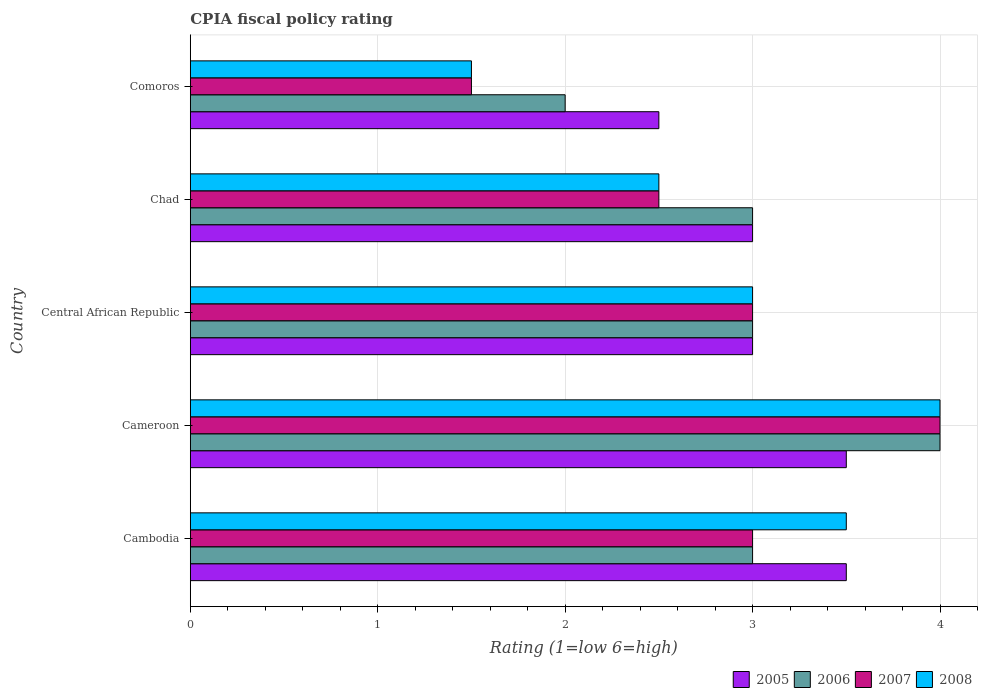How many different coloured bars are there?
Provide a short and direct response. 4. How many groups of bars are there?
Provide a short and direct response. 5. How many bars are there on the 3rd tick from the bottom?
Your answer should be very brief. 4. What is the label of the 4th group of bars from the top?
Give a very brief answer. Cameroon. Across all countries, what is the minimum CPIA rating in 2007?
Keep it short and to the point. 1.5. In which country was the CPIA rating in 2007 maximum?
Your answer should be very brief. Cameroon. In which country was the CPIA rating in 2006 minimum?
Make the answer very short. Comoros. What is the difference between the CPIA rating in 2008 in Cambodia and that in Comoros?
Provide a short and direct response. 2. What is the average CPIA rating in 2008 per country?
Offer a very short reply. 2.9. In how many countries, is the CPIA rating in 2006 greater than 0.2 ?
Your response must be concise. 5. What is the ratio of the CPIA rating in 2008 in Cameroon to that in Central African Republic?
Offer a very short reply. 1.33. Is the CPIA rating in 2005 in Cameroon less than that in Chad?
Your response must be concise. No. What is the difference between the highest and the lowest CPIA rating in 2005?
Your answer should be compact. 1. In how many countries, is the CPIA rating in 2006 greater than the average CPIA rating in 2006 taken over all countries?
Your response must be concise. 1. Is the sum of the CPIA rating in 2007 in Chad and Comoros greater than the maximum CPIA rating in 2006 across all countries?
Your response must be concise. No. Is it the case that in every country, the sum of the CPIA rating in 2008 and CPIA rating in 2005 is greater than the sum of CPIA rating in 2006 and CPIA rating in 2007?
Provide a short and direct response. No. Is it the case that in every country, the sum of the CPIA rating in 2008 and CPIA rating in 2007 is greater than the CPIA rating in 2006?
Ensure brevity in your answer.  Yes. Are all the bars in the graph horizontal?
Make the answer very short. Yes. How many countries are there in the graph?
Offer a terse response. 5. Does the graph contain grids?
Provide a succinct answer. Yes. How many legend labels are there?
Offer a very short reply. 4. What is the title of the graph?
Your answer should be compact. CPIA fiscal policy rating. Does "1984" appear as one of the legend labels in the graph?
Offer a terse response. No. What is the label or title of the X-axis?
Give a very brief answer. Rating (1=low 6=high). What is the Rating (1=low 6=high) in 2006 in Cambodia?
Offer a terse response. 3. What is the Rating (1=low 6=high) in 2007 in Cambodia?
Keep it short and to the point. 3. What is the Rating (1=low 6=high) in 2008 in Cambodia?
Give a very brief answer. 3.5. What is the Rating (1=low 6=high) of 2007 in Cameroon?
Offer a terse response. 4. What is the Rating (1=low 6=high) in 2005 in Central African Republic?
Your response must be concise. 3. What is the Rating (1=low 6=high) in 2006 in Central African Republic?
Offer a terse response. 3. What is the Rating (1=low 6=high) of 2007 in Central African Republic?
Your answer should be very brief. 3. What is the Rating (1=low 6=high) of 2005 in Chad?
Offer a terse response. 3. What is the Rating (1=low 6=high) in 2007 in Chad?
Provide a short and direct response. 2.5. What is the Rating (1=low 6=high) in 2006 in Comoros?
Provide a short and direct response. 2. What is the Rating (1=low 6=high) in 2007 in Comoros?
Give a very brief answer. 1.5. What is the Rating (1=low 6=high) of 2008 in Comoros?
Your response must be concise. 1.5. Across all countries, what is the maximum Rating (1=low 6=high) of 2007?
Offer a very short reply. 4. Across all countries, what is the maximum Rating (1=low 6=high) of 2008?
Offer a terse response. 4. What is the total Rating (1=low 6=high) of 2006 in the graph?
Offer a terse response. 15. What is the total Rating (1=low 6=high) of 2007 in the graph?
Provide a short and direct response. 14. What is the difference between the Rating (1=low 6=high) in 2005 in Cambodia and that in Cameroon?
Your response must be concise. 0. What is the difference between the Rating (1=low 6=high) of 2007 in Cambodia and that in Cameroon?
Keep it short and to the point. -1. What is the difference between the Rating (1=low 6=high) in 2005 in Cambodia and that in Central African Republic?
Give a very brief answer. 0.5. What is the difference between the Rating (1=low 6=high) of 2006 in Cambodia and that in Central African Republic?
Provide a short and direct response. 0. What is the difference between the Rating (1=low 6=high) in 2007 in Cambodia and that in Central African Republic?
Your response must be concise. 0. What is the difference between the Rating (1=low 6=high) of 2006 in Cambodia and that in Chad?
Provide a short and direct response. 0. What is the difference between the Rating (1=low 6=high) in 2007 in Cambodia and that in Chad?
Keep it short and to the point. 0.5. What is the difference between the Rating (1=low 6=high) of 2008 in Cambodia and that in Chad?
Give a very brief answer. 1. What is the difference between the Rating (1=low 6=high) of 2005 in Cambodia and that in Comoros?
Your response must be concise. 1. What is the difference between the Rating (1=low 6=high) in 2006 in Cambodia and that in Comoros?
Offer a terse response. 1. What is the difference between the Rating (1=low 6=high) of 2007 in Cambodia and that in Comoros?
Ensure brevity in your answer.  1.5. What is the difference between the Rating (1=low 6=high) of 2007 in Cameroon and that in Central African Republic?
Provide a succinct answer. 1. What is the difference between the Rating (1=low 6=high) in 2006 in Cameroon and that in Chad?
Your response must be concise. 1. What is the difference between the Rating (1=low 6=high) in 2008 in Cameroon and that in Chad?
Your answer should be very brief. 1.5. What is the difference between the Rating (1=low 6=high) of 2005 in Cameroon and that in Comoros?
Make the answer very short. 1. What is the difference between the Rating (1=low 6=high) in 2008 in Cameroon and that in Comoros?
Your response must be concise. 2.5. What is the difference between the Rating (1=low 6=high) in 2005 in Central African Republic and that in Comoros?
Offer a very short reply. 0.5. What is the difference between the Rating (1=low 6=high) in 2006 in Central African Republic and that in Comoros?
Your answer should be compact. 1. What is the difference between the Rating (1=low 6=high) in 2007 in Central African Republic and that in Comoros?
Offer a terse response. 1.5. What is the difference between the Rating (1=low 6=high) of 2005 in Chad and that in Comoros?
Your answer should be compact. 0.5. What is the difference between the Rating (1=low 6=high) in 2006 in Chad and that in Comoros?
Your response must be concise. 1. What is the difference between the Rating (1=low 6=high) in 2007 in Chad and that in Comoros?
Ensure brevity in your answer.  1. What is the difference between the Rating (1=low 6=high) of 2008 in Chad and that in Comoros?
Your response must be concise. 1. What is the difference between the Rating (1=low 6=high) of 2005 in Cambodia and the Rating (1=low 6=high) of 2006 in Cameroon?
Provide a short and direct response. -0.5. What is the difference between the Rating (1=low 6=high) of 2005 in Cambodia and the Rating (1=low 6=high) of 2007 in Cameroon?
Make the answer very short. -0.5. What is the difference between the Rating (1=low 6=high) in 2005 in Cambodia and the Rating (1=low 6=high) in 2008 in Cameroon?
Give a very brief answer. -0.5. What is the difference between the Rating (1=low 6=high) in 2006 in Cambodia and the Rating (1=low 6=high) in 2008 in Cameroon?
Your answer should be compact. -1. What is the difference between the Rating (1=low 6=high) of 2007 in Cambodia and the Rating (1=low 6=high) of 2008 in Cameroon?
Keep it short and to the point. -1. What is the difference between the Rating (1=low 6=high) in 2005 in Cambodia and the Rating (1=low 6=high) in 2007 in Central African Republic?
Give a very brief answer. 0.5. What is the difference between the Rating (1=low 6=high) of 2006 in Cambodia and the Rating (1=low 6=high) of 2007 in Central African Republic?
Offer a terse response. 0. What is the difference between the Rating (1=low 6=high) of 2007 in Cambodia and the Rating (1=low 6=high) of 2008 in Central African Republic?
Give a very brief answer. 0. What is the difference between the Rating (1=low 6=high) in 2006 in Cambodia and the Rating (1=low 6=high) in 2007 in Chad?
Ensure brevity in your answer.  0.5. What is the difference between the Rating (1=low 6=high) of 2005 in Cambodia and the Rating (1=low 6=high) of 2008 in Comoros?
Your answer should be compact. 2. What is the difference between the Rating (1=low 6=high) in 2006 in Cameroon and the Rating (1=low 6=high) in 2008 in Central African Republic?
Your answer should be compact. 1. What is the difference between the Rating (1=low 6=high) of 2007 in Cameroon and the Rating (1=low 6=high) of 2008 in Central African Republic?
Make the answer very short. 1. What is the difference between the Rating (1=low 6=high) of 2006 in Cameroon and the Rating (1=low 6=high) of 2008 in Chad?
Provide a short and direct response. 1.5. What is the difference between the Rating (1=low 6=high) in 2005 in Cameroon and the Rating (1=low 6=high) in 2008 in Comoros?
Your answer should be compact. 2. What is the difference between the Rating (1=low 6=high) of 2006 in Cameroon and the Rating (1=low 6=high) of 2008 in Comoros?
Offer a terse response. 2.5. What is the difference between the Rating (1=low 6=high) of 2006 in Central African Republic and the Rating (1=low 6=high) of 2007 in Chad?
Keep it short and to the point. 0.5. What is the difference between the Rating (1=low 6=high) of 2005 in Central African Republic and the Rating (1=low 6=high) of 2007 in Comoros?
Provide a short and direct response. 1.5. What is the difference between the Rating (1=low 6=high) in 2005 in Central African Republic and the Rating (1=low 6=high) in 2008 in Comoros?
Ensure brevity in your answer.  1.5. What is the difference between the Rating (1=low 6=high) of 2006 in Central African Republic and the Rating (1=low 6=high) of 2007 in Comoros?
Provide a short and direct response. 1.5. What is the difference between the Rating (1=low 6=high) in 2006 in Central African Republic and the Rating (1=low 6=high) in 2008 in Comoros?
Provide a succinct answer. 1.5. What is the difference between the Rating (1=low 6=high) of 2007 in Central African Republic and the Rating (1=low 6=high) of 2008 in Comoros?
Make the answer very short. 1.5. What is the difference between the Rating (1=low 6=high) of 2005 in Chad and the Rating (1=low 6=high) of 2006 in Comoros?
Offer a terse response. 1. What is the difference between the Rating (1=low 6=high) of 2005 in Chad and the Rating (1=low 6=high) of 2007 in Comoros?
Provide a short and direct response. 1.5. What is the difference between the Rating (1=low 6=high) of 2006 in Chad and the Rating (1=low 6=high) of 2008 in Comoros?
Your answer should be compact. 1.5. What is the average Rating (1=low 6=high) of 2006 per country?
Your answer should be compact. 3. What is the difference between the Rating (1=low 6=high) of 2005 and Rating (1=low 6=high) of 2007 in Cambodia?
Ensure brevity in your answer.  0.5. What is the difference between the Rating (1=low 6=high) of 2005 and Rating (1=low 6=high) of 2008 in Cameroon?
Provide a succinct answer. -0.5. What is the difference between the Rating (1=low 6=high) in 2006 and Rating (1=low 6=high) in 2007 in Cameroon?
Provide a short and direct response. 0. What is the difference between the Rating (1=low 6=high) in 2007 and Rating (1=low 6=high) in 2008 in Cameroon?
Provide a short and direct response. 0. What is the difference between the Rating (1=low 6=high) in 2005 and Rating (1=low 6=high) in 2007 in Central African Republic?
Give a very brief answer. 0. What is the difference between the Rating (1=low 6=high) of 2006 and Rating (1=low 6=high) of 2008 in Central African Republic?
Your response must be concise. 0. What is the difference between the Rating (1=low 6=high) of 2005 and Rating (1=low 6=high) of 2006 in Chad?
Your answer should be very brief. 0. What is the difference between the Rating (1=low 6=high) in 2005 and Rating (1=low 6=high) in 2007 in Chad?
Your response must be concise. 0.5. What is the difference between the Rating (1=low 6=high) in 2005 and Rating (1=low 6=high) in 2008 in Chad?
Your answer should be compact. 0.5. What is the difference between the Rating (1=low 6=high) in 2006 and Rating (1=low 6=high) in 2007 in Chad?
Ensure brevity in your answer.  0.5. What is the difference between the Rating (1=low 6=high) of 2006 and Rating (1=low 6=high) of 2008 in Chad?
Provide a succinct answer. 0.5. What is the difference between the Rating (1=low 6=high) in 2007 and Rating (1=low 6=high) in 2008 in Chad?
Provide a succinct answer. 0. What is the difference between the Rating (1=low 6=high) in 2005 and Rating (1=low 6=high) in 2008 in Comoros?
Make the answer very short. 1. What is the difference between the Rating (1=low 6=high) in 2006 and Rating (1=low 6=high) in 2007 in Comoros?
Make the answer very short. 0.5. What is the difference between the Rating (1=low 6=high) in 2006 and Rating (1=low 6=high) in 2008 in Comoros?
Provide a succinct answer. 0.5. What is the ratio of the Rating (1=low 6=high) of 2005 in Cambodia to that in Central African Republic?
Your answer should be very brief. 1.17. What is the ratio of the Rating (1=low 6=high) in 2008 in Cambodia to that in Central African Republic?
Provide a short and direct response. 1.17. What is the ratio of the Rating (1=low 6=high) of 2005 in Cambodia to that in Chad?
Provide a short and direct response. 1.17. What is the ratio of the Rating (1=low 6=high) in 2006 in Cambodia to that in Chad?
Your answer should be compact. 1. What is the ratio of the Rating (1=low 6=high) in 2008 in Cambodia to that in Comoros?
Ensure brevity in your answer.  2.33. What is the ratio of the Rating (1=low 6=high) in 2006 in Cameroon to that in Central African Republic?
Offer a very short reply. 1.33. What is the ratio of the Rating (1=low 6=high) in 2008 in Cameroon to that in Central African Republic?
Your answer should be very brief. 1.33. What is the ratio of the Rating (1=low 6=high) in 2006 in Cameroon to that in Chad?
Your response must be concise. 1.33. What is the ratio of the Rating (1=low 6=high) of 2007 in Cameroon to that in Chad?
Give a very brief answer. 1.6. What is the ratio of the Rating (1=low 6=high) of 2008 in Cameroon to that in Chad?
Provide a succinct answer. 1.6. What is the ratio of the Rating (1=low 6=high) in 2005 in Cameroon to that in Comoros?
Make the answer very short. 1.4. What is the ratio of the Rating (1=low 6=high) of 2007 in Cameroon to that in Comoros?
Your answer should be compact. 2.67. What is the ratio of the Rating (1=low 6=high) in 2008 in Cameroon to that in Comoros?
Give a very brief answer. 2.67. What is the ratio of the Rating (1=low 6=high) in 2005 in Central African Republic to that in Chad?
Keep it short and to the point. 1. What is the ratio of the Rating (1=low 6=high) in 2008 in Central African Republic to that in Chad?
Your answer should be compact. 1.2. What is the ratio of the Rating (1=low 6=high) in 2005 in Central African Republic to that in Comoros?
Offer a terse response. 1.2. What is the ratio of the Rating (1=low 6=high) of 2008 in Central African Republic to that in Comoros?
Ensure brevity in your answer.  2. What is the ratio of the Rating (1=low 6=high) of 2005 in Chad to that in Comoros?
Make the answer very short. 1.2. What is the ratio of the Rating (1=low 6=high) of 2006 in Chad to that in Comoros?
Provide a succinct answer. 1.5. What is the difference between the highest and the second highest Rating (1=low 6=high) in 2005?
Keep it short and to the point. 0. What is the difference between the highest and the second highest Rating (1=low 6=high) of 2007?
Make the answer very short. 1. What is the difference between the highest and the second highest Rating (1=low 6=high) of 2008?
Keep it short and to the point. 0.5. What is the difference between the highest and the lowest Rating (1=low 6=high) in 2006?
Make the answer very short. 2. What is the difference between the highest and the lowest Rating (1=low 6=high) in 2008?
Your answer should be very brief. 2.5. 